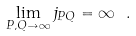Convert formula to latex. <formula><loc_0><loc_0><loc_500><loc_500>\lim _ { P , Q \to \infty } j _ { P Q } = \infty \ .</formula> 